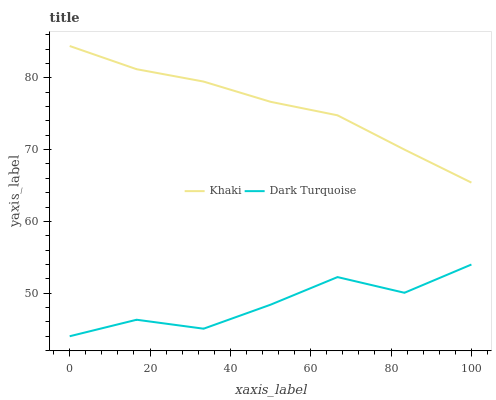Does Dark Turquoise have the minimum area under the curve?
Answer yes or no. Yes. Does Khaki have the maximum area under the curve?
Answer yes or no. Yes. Does Khaki have the minimum area under the curve?
Answer yes or no. No. Is Khaki the smoothest?
Answer yes or no. Yes. Is Dark Turquoise the roughest?
Answer yes or no. Yes. Is Khaki the roughest?
Answer yes or no. No. Does Dark Turquoise have the lowest value?
Answer yes or no. Yes. Does Khaki have the lowest value?
Answer yes or no. No. Does Khaki have the highest value?
Answer yes or no. Yes. Is Dark Turquoise less than Khaki?
Answer yes or no. Yes. Is Khaki greater than Dark Turquoise?
Answer yes or no. Yes. Does Dark Turquoise intersect Khaki?
Answer yes or no. No. 